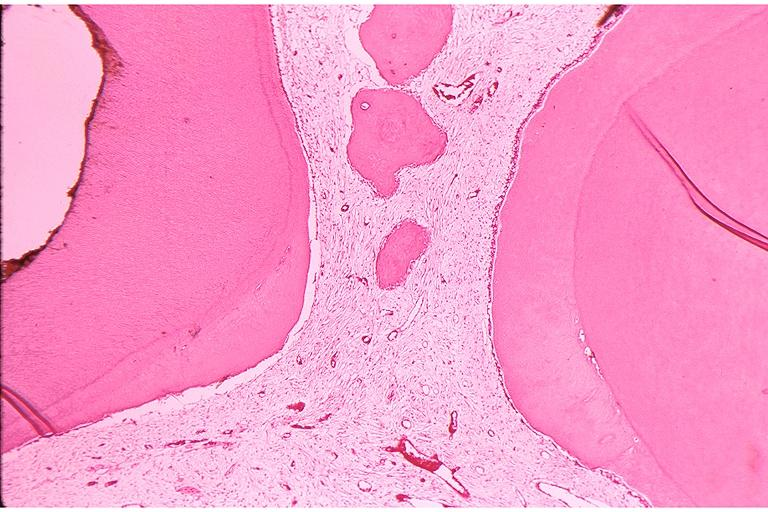s granuloma present?
Answer the question using a single word or phrase. No 